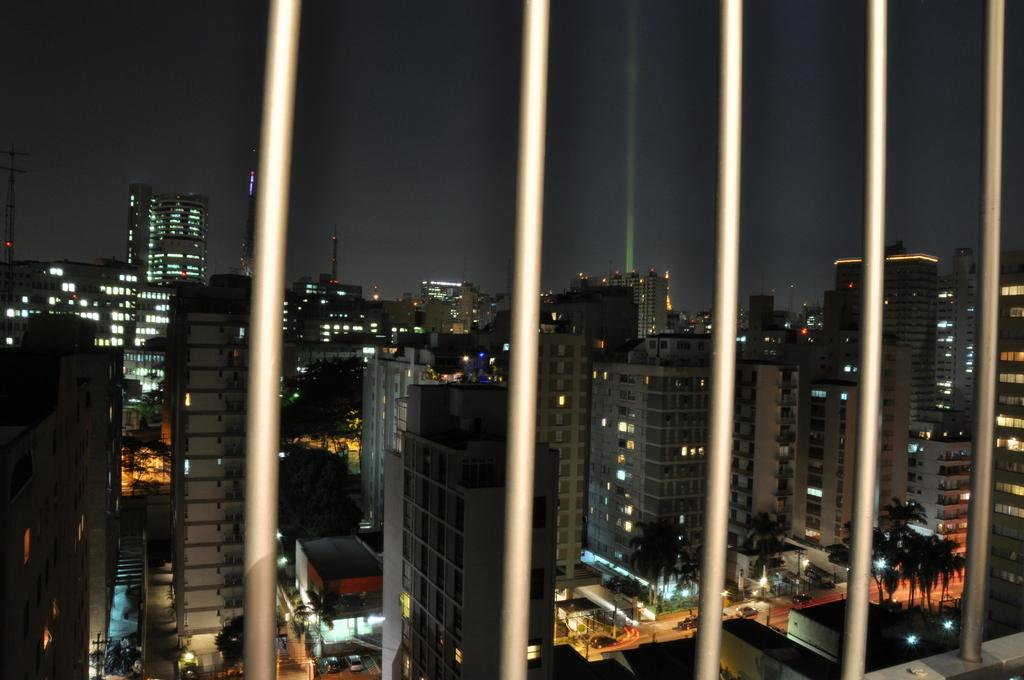What is the main subject in the center of the image? There are buildings in the center of the image. Can you describe the time of day when the image was captured? The image appears to be captured during night time. What type of fowl can be seen roosting on the buildings in the image? There are no fowl visible in the image; it only shows buildings during night time. Can you describe the quill used for writing in the image? There is no quill present in the image. 